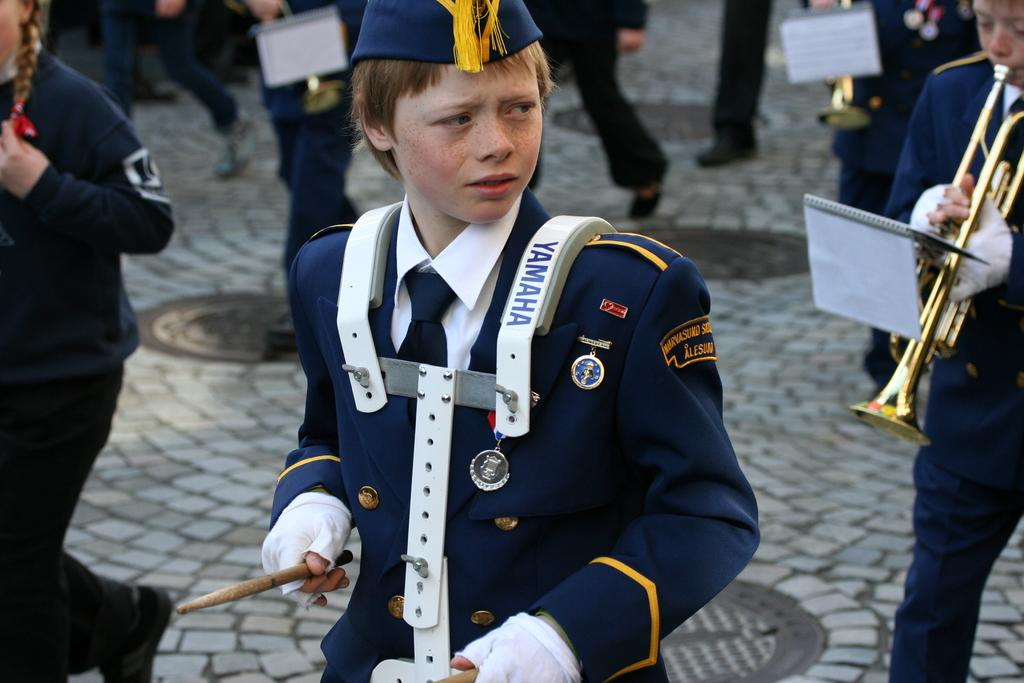What are the people in the image doing? The people in the image are playing musical instruments. What else can be seen in the image besides the people playing instruments? There are books in the image. Can you describe the background of the image? The background of the image is blurred. What type of shop can be seen in the background of the image? There is no shop visible in the image; the background is blurred. How does the acoustics of the room affect the sound of the instruments being played? The acoustics of the room cannot be determined from the image, as there is no information about the room's structure or materials. 